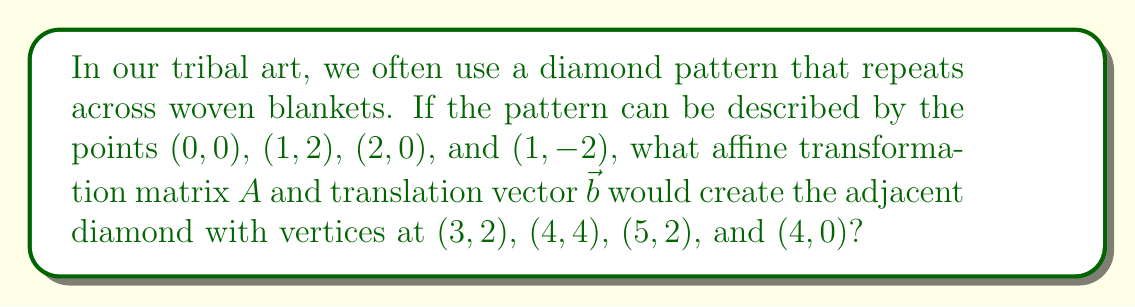Solve this math problem. Let's approach this step-by-step:

1) An affine transformation has the form $T(\vec{x}) = A\vec{x} + \vec{b}$, where $A$ is a 2x2 matrix and $\vec{b}$ is a translation vector.

2) First, we need to determine if there's any scaling or rotation. Let's compare the original diamond to the new one:
   - The width remains 2 units (from 0 to 2, and 3 to 5)
   - The height remains 4 units (from -2 to 2, and 0 to 4)
   This suggests no scaling or rotation is involved, so $A = \begin{pmatrix} 1 & 0 \\ 0 & 1 \end{pmatrix}$.

3) Now, let's find the translation vector $\vec{b}$. We can do this by comparing any pair of corresponding points:
   $(0,0) \rightarrow (3,2)$
   This suggests a translation of 3 units right and 2 units up.

4) Therefore, $\vec{b} = \begin{pmatrix} 3 \\ 2 \end{pmatrix}$.

5) We can verify this transformation:
   $T\begin{pmatrix} 0 \\ 0 \end{pmatrix} = \begin{pmatrix} 1 & 0 \\ 0 & 1 \end{pmatrix}\begin{pmatrix} 0 \\ 0 \end{pmatrix} + \begin{pmatrix} 3 \\ 2 \end{pmatrix} = \begin{pmatrix} 3 \\ 2 \end{pmatrix}$
   $T\begin{pmatrix} 1 \\ 2 \end{pmatrix} = \begin{pmatrix} 1 & 0 \\ 0 & 1 \end{pmatrix}\begin{pmatrix} 1 \\ 2 \end{pmatrix} + \begin{pmatrix} 3 \\ 2 \end{pmatrix} = \begin{pmatrix} 4 \\ 4 \end{pmatrix}$
   And so on for the other points.
Answer: $A = \begin{pmatrix} 1 & 0 \\ 0 & 1 \end{pmatrix}$, $\vec{b} = \begin{pmatrix} 3 \\ 2 \end{pmatrix}$ 